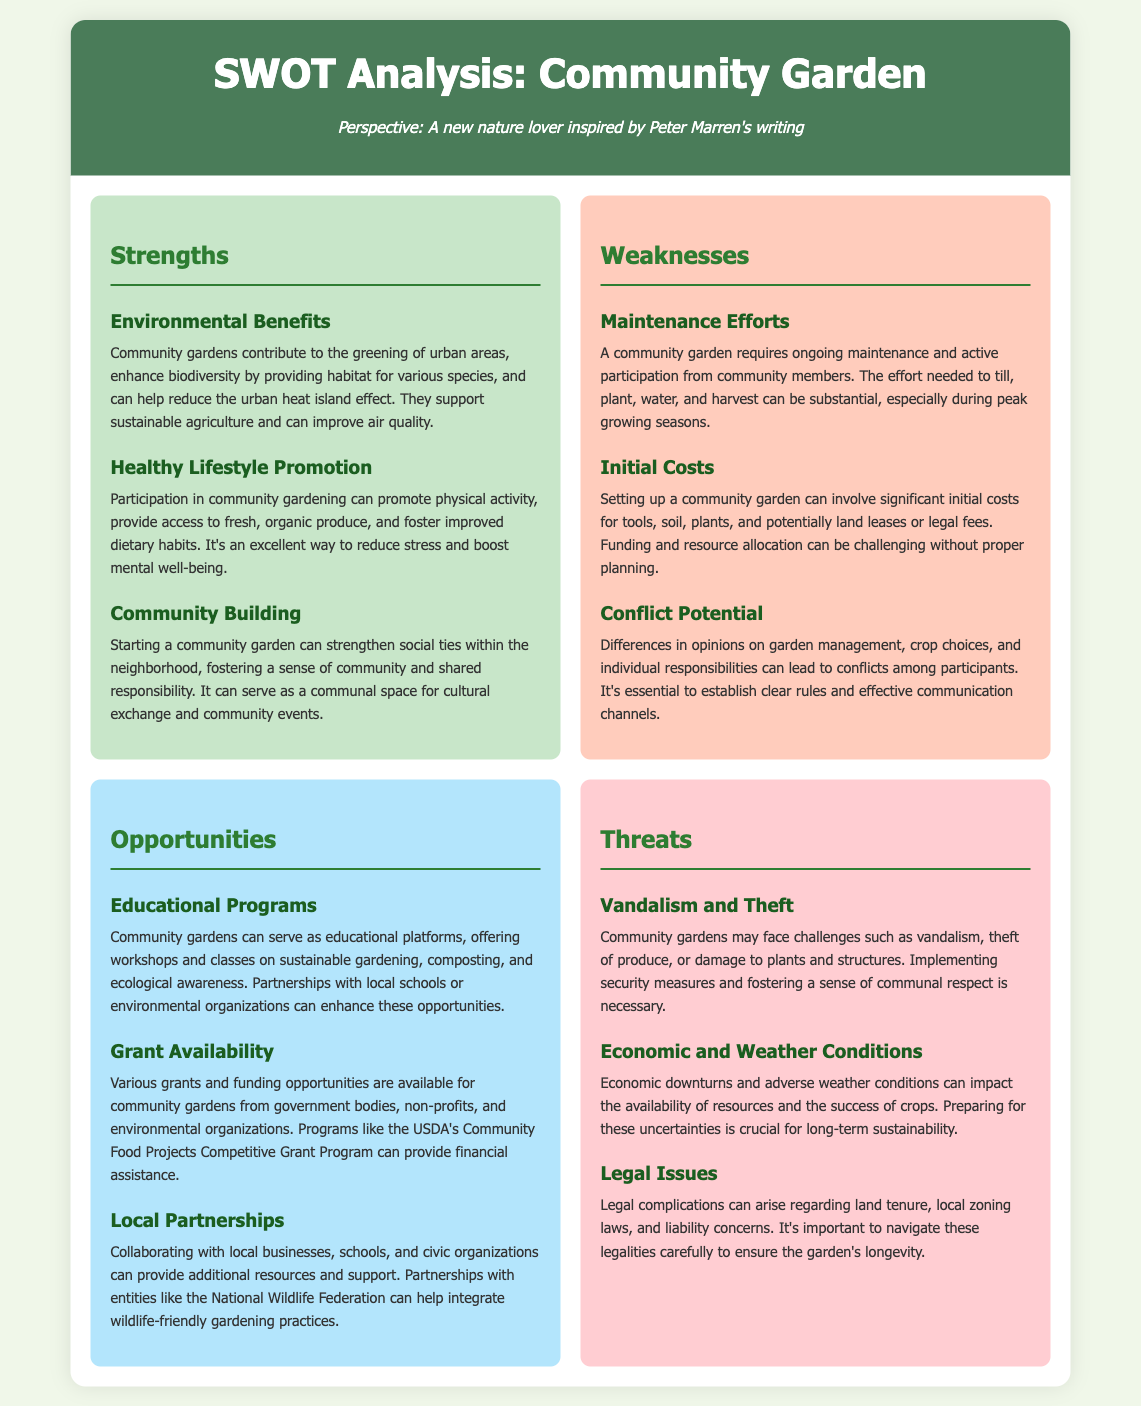What are the environmental benefits of community gardens? The document lists several environmental benefits, including greening urban areas, enhancing biodiversity, and improving air quality.
Answer: Environmental Benefits What is one opportunity mentioned for community gardens? The document states that community gardens can serve as educational platforms offering workshops and classes.
Answer: Educational Programs How many weaknesses are identified in the document? The document outlines three weaknesses related to community gardens.
Answer: Three What threat involves potential damage to a community garden? The document mentions vandalism and theft as threats to community gardens.
Answer: Vandalism and Theft What does the document suggest is essential to avoid conflicts among participants? The document emphasizes the need for clear rules and effective communication channels to prevent conflicts.
Answer: Clear rules and effective communication What is one way to promote a healthy lifestyle mentioned in the strengths? The document notes that participation in community gardening promotes physical activity.
Answer: Physical activity What kind of grants are mentioned as opportunities for community gardens? The document refers to various grants available from government bodies and non-profits.
Answer: Grants What is one challenge linked to weather conditions in the threats section? The document highlights that adverse weather conditions can impact the success of crops.
Answer: Adverse weather conditions 